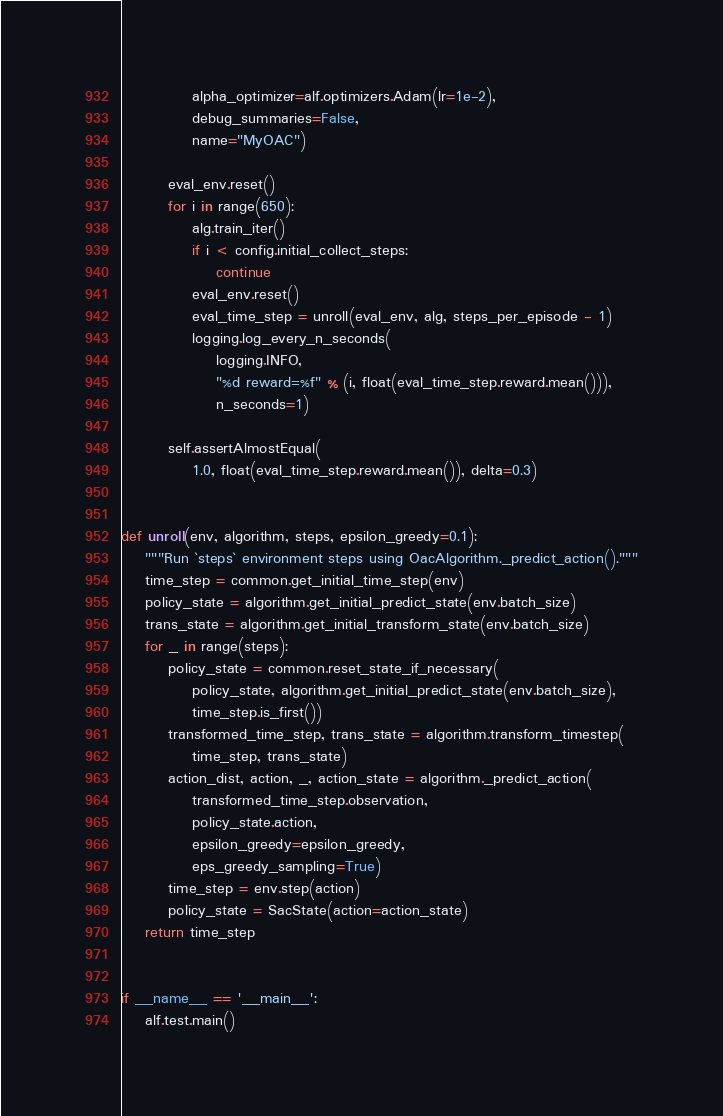<code> <loc_0><loc_0><loc_500><loc_500><_Python_>            alpha_optimizer=alf.optimizers.Adam(lr=1e-2),
            debug_summaries=False,
            name="MyOAC")

        eval_env.reset()
        for i in range(650):
            alg.train_iter()
            if i < config.initial_collect_steps:
                continue
            eval_env.reset()
            eval_time_step = unroll(eval_env, alg, steps_per_episode - 1)
            logging.log_every_n_seconds(
                logging.INFO,
                "%d reward=%f" % (i, float(eval_time_step.reward.mean())),
                n_seconds=1)

        self.assertAlmostEqual(
            1.0, float(eval_time_step.reward.mean()), delta=0.3)


def unroll(env, algorithm, steps, epsilon_greedy=0.1):
    """Run `steps` environment steps using OacAlgorithm._predict_action()."""
    time_step = common.get_initial_time_step(env)
    policy_state = algorithm.get_initial_predict_state(env.batch_size)
    trans_state = algorithm.get_initial_transform_state(env.batch_size)
    for _ in range(steps):
        policy_state = common.reset_state_if_necessary(
            policy_state, algorithm.get_initial_predict_state(env.batch_size),
            time_step.is_first())
        transformed_time_step, trans_state = algorithm.transform_timestep(
            time_step, trans_state)
        action_dist, action, _, action_state = algorithm._predict_action(
            transformed_time_step.observation,
            policy_state.action,
            epsilon_greedy=epsilon_greedy,
            eps_greedy_sampling=True)
        time_step = env.step(action)
        policy_state = SacState(action=action_state)
    return time_step


if __name__ == '__main__':
    alf.test.main()
</code> 